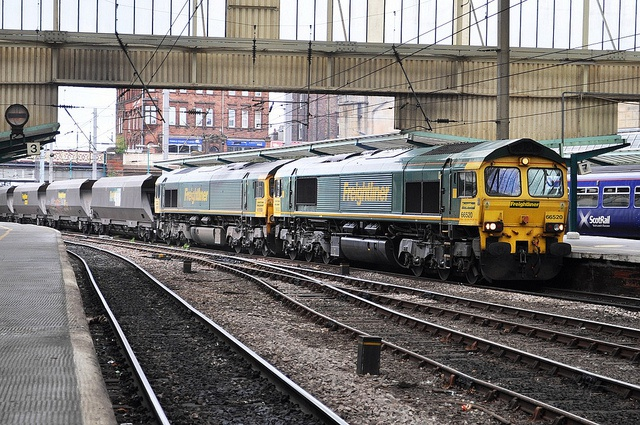Describe the objects in this image and their specific colors. I can see train in white, black, gray, darkgray, and lightgray tones and train in white, black, gray, lavender, and navy tones in this image. 